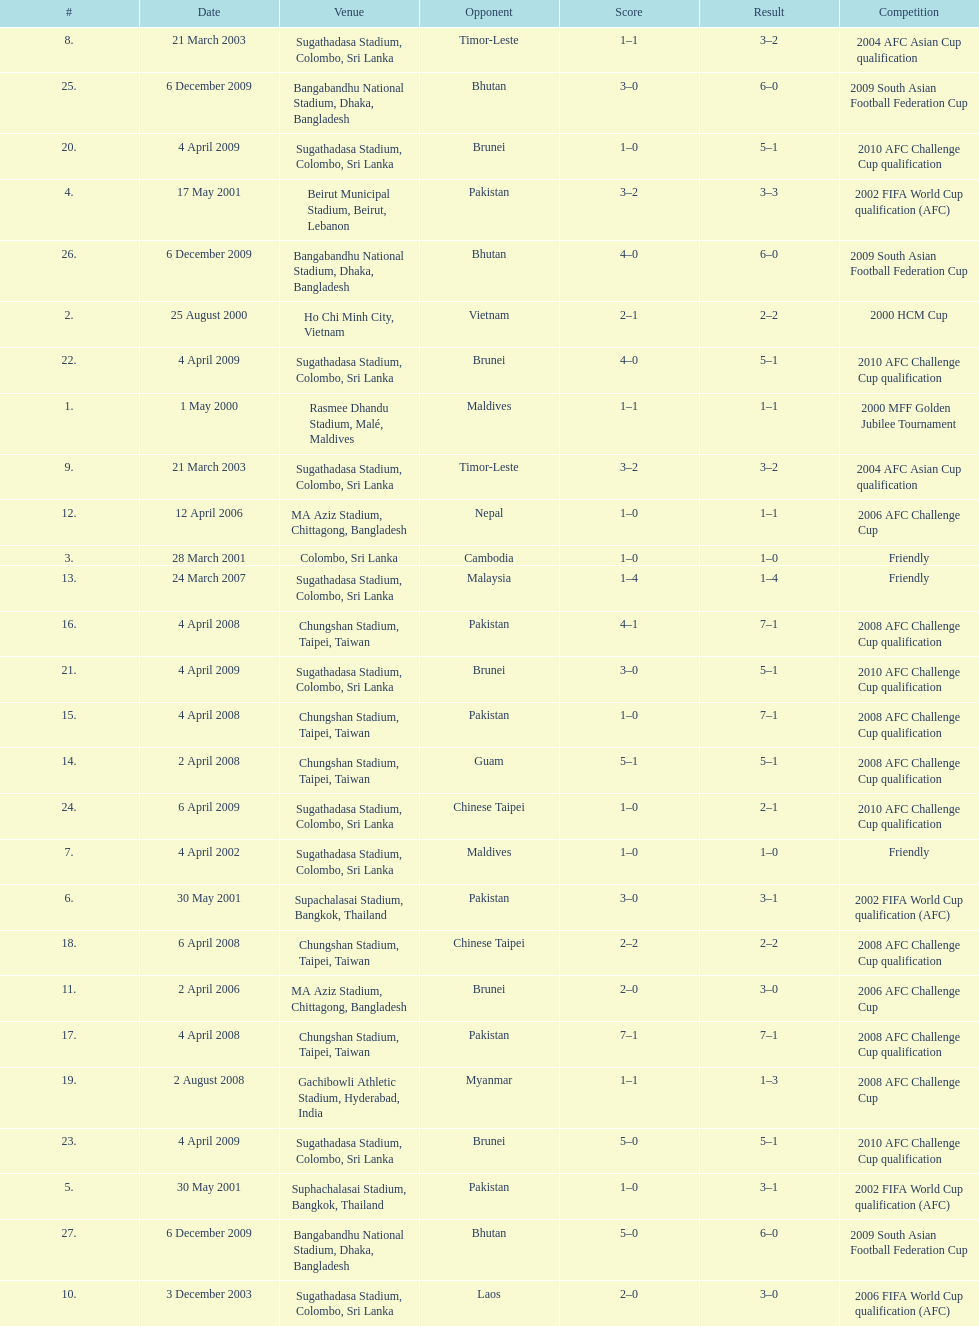Which team did this player face before pakistan on april 4, 2008? Guam. 